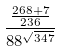Convert formula to latex. <formula><loc_0><loc_0><loc_500><loc_500>\frac { \frac { 2 6 8 + 7 } { 2 3 6 } } { 8 8 ^ { \sqrt { 3 4 7 } } }</formula> 